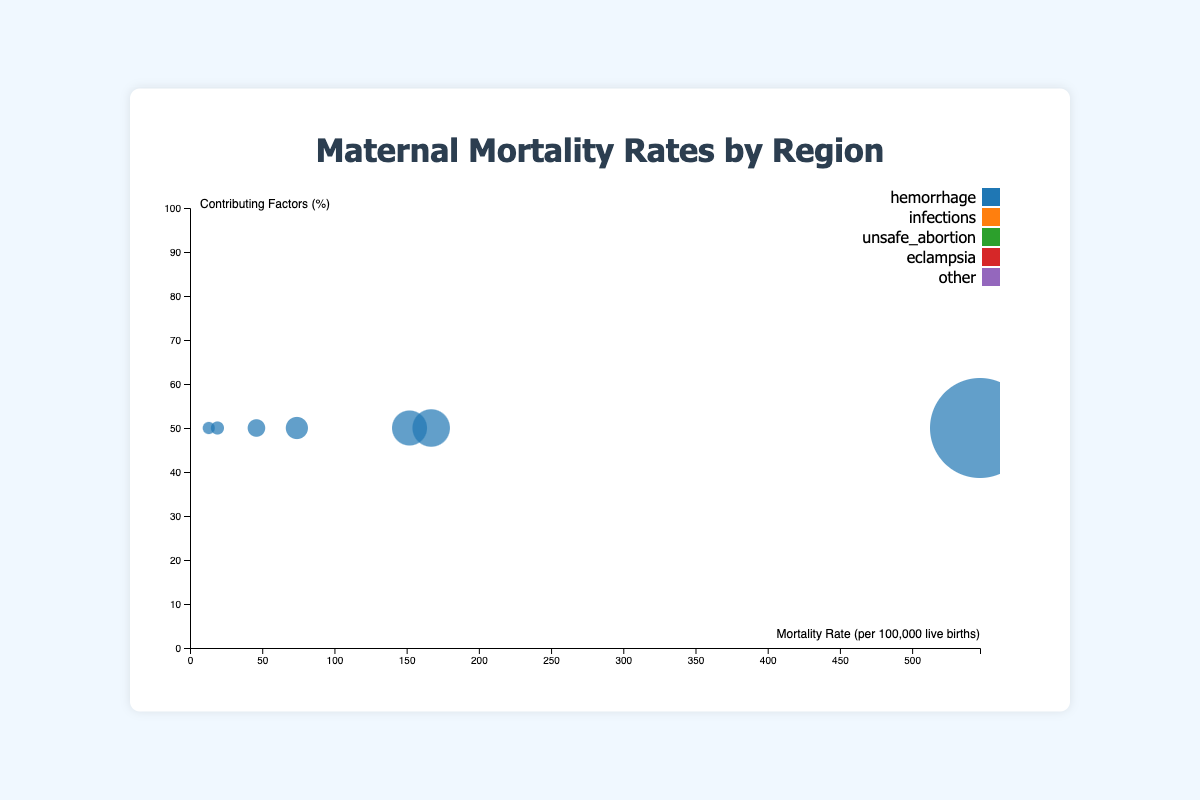What is the maternal mortality rate in Sub-Saharan Africa? The chart shows that the maternal mortality rate for Sub-Saharan Africa is represented by the size of the bubble and is labeled directly.
Answer: 547 What are the five contributing factors to maternal mortality shown in the chart? The tooltip in the chart lists the contributing factors for each region: hemorrhage, infections, unsafe abortion, eclampsia, and other
Answer: Hemorrhage, Infections, Unsafe Abortion, Eclampsia, Other Which region has the lowest maternal mortality rate? By examining the x-axis which represents mortality rate and the corresponding bubbles, the smallest rate is found in the region represented by the smallest bubble on the far left.
Answer: Europe What is the percentage of maternal deaths due to eclampsia in South Asia? When hovering over the bubble for South Asia, the tooltip shows the breakdown of contributing factors including eclampsia.
Answer: 25% How does the maternal mortality rate in Southeast Asia compare to that of Latin America? By comparing the positions of the bubbles on the x-axis, we can see that Southeast Asia has a higher maternal mortality rate than Latin America.
Answer: Higher Which region shows the highest percentage of maternal deaths due to unsafe abortions? Hovering over each bubble and examining the tooltips reveals that Latin America has the highest percentage for unsafe abortions, at 15%.
Answer: Latin America What is the sum of the percentages of deaths due to hemorrhage and infections in the Middle East? Summing the percentages for hemorrhage (19%) and infections (21%) in the Middle East gives the total.
Answer: 40% Which region has the highest percentage of maternal deaths caused by 'other' factors and what is that percentage? Hovering over each region's bubble and examining the tooltips, North America shows the highest 'other' percentage, at 40%.
Answer: North America, 40% What is the range of maternal mortality rates depicted in the chart? The lowest mortality rate is in Europe (13) and the highest is in Sub-Saharan Africa (547). Subtract the lowest from the highest to get the range.
Answer: 534 In which region is the percentage of deaths due to hemorrhage the closest to the percentage of deaths due to infections? By comparing the hemorrhage and infections percentages across regions, Sub-Saharan Africa has 27% (hemorrhage) and 28% (infections), the closest values.
Answer: Sub-Saharan Africa 